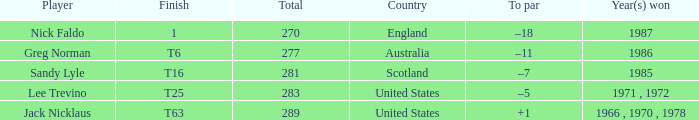What player has 1 as the place? Nick Faldo. 